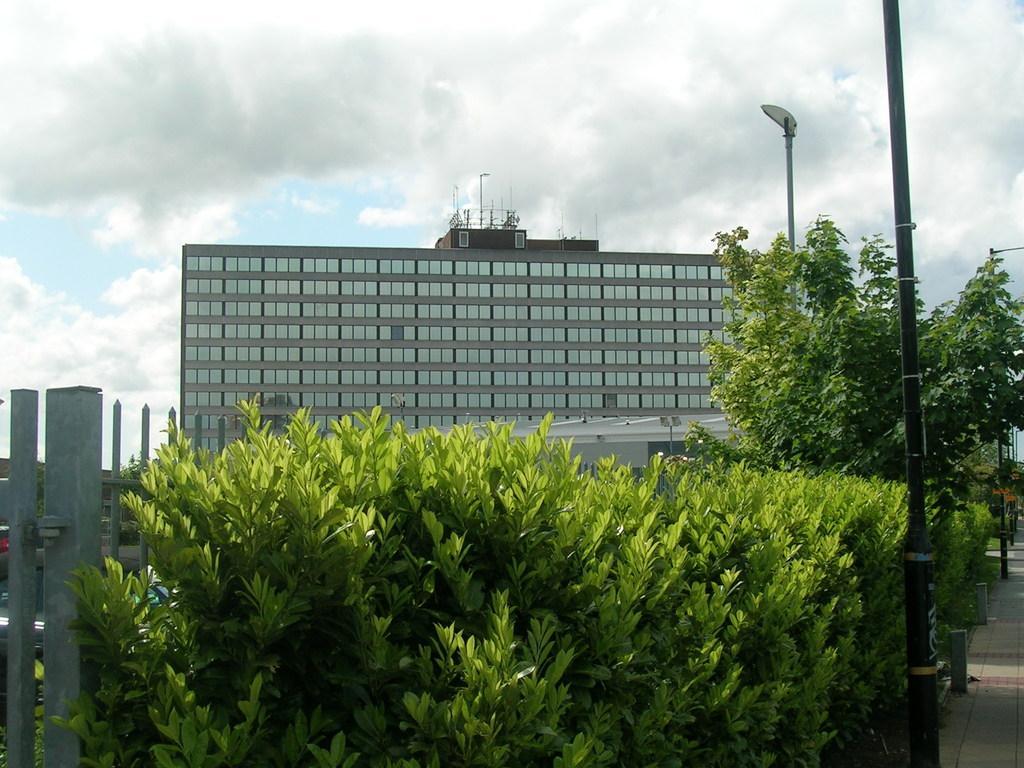How would you summarize this image in a sentence or two? At the bottom of the image there are plants and also there are trees. At the right corner of the image there is a fencing. And at the bottom left of the image there is a footpath with poles. In the background there is a building with glass windows and on the top of the building there are poles. At the top of the image there is a sky with clouds. 